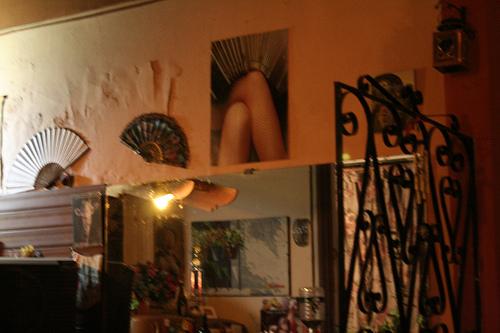How many fans are on the wall?
Quick response, please. 2. How many plates hang on the wall?
Quick response, please. 0. What is on the lampshade?
Concise answer only. Nothing. Bedroom or dressing room?
Quick response, please. Bedroom. What color is the ceiling?
Answer briefly. Brown. Are there any reflections visible?
Concise answer only. Yes. Is this someone's living room?
Keep it brief. No. 